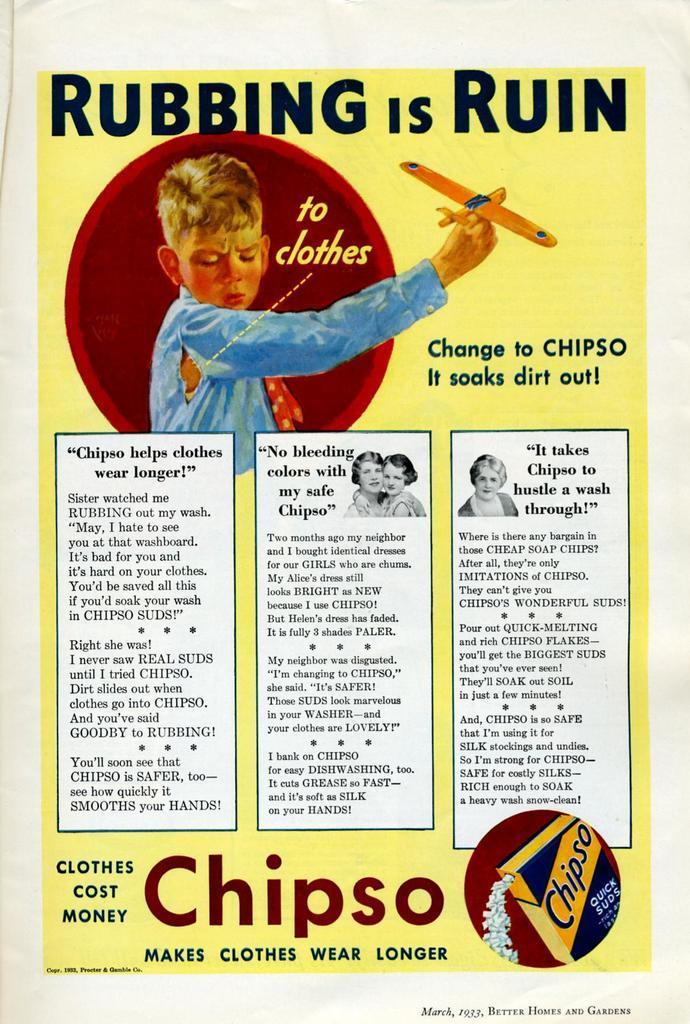<image>
Present a compact description of the photo's key features. A poster for Chipso clothes stating : Rubbing is Ruin. 